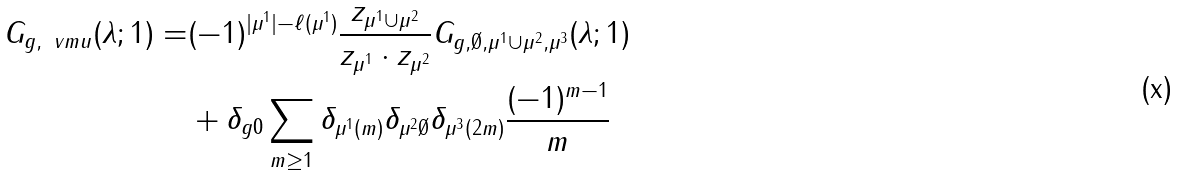<formula> <loc_0><loc_0><loc_500><loc_500>G _ { g , \ v m u } ( \lambda ; 1 ) = & ( - 1 ) ^ { | \mu ^ { 1 } | - \ell ( \mu ^ { 1 } ) } \frac { z _ { \mu ^ { 1 } \cup \mu ^ { 2 } } } { z _ { \mu ^ { 1 } } \cdot z _ { \mu ^ { 2 } } } G _ { g , \emptyset , \mu ^ { 1 } \cup \mu ^ { 2 } , \mu ^ { 3 } } ( \lambda ; 1 ) \\ & + \delta _ { g 0 } \sum _ { m \geq 1 } \delta _ { \mu ^ { 1 } ( m ) } \delta _ { \mu ^ { 2 } \emptyset } \delta _ { \mu ^ { 3 } ( 2 m ) } \frac { ( - 1 ) ^ { m - 1 } } { m }</formula> 